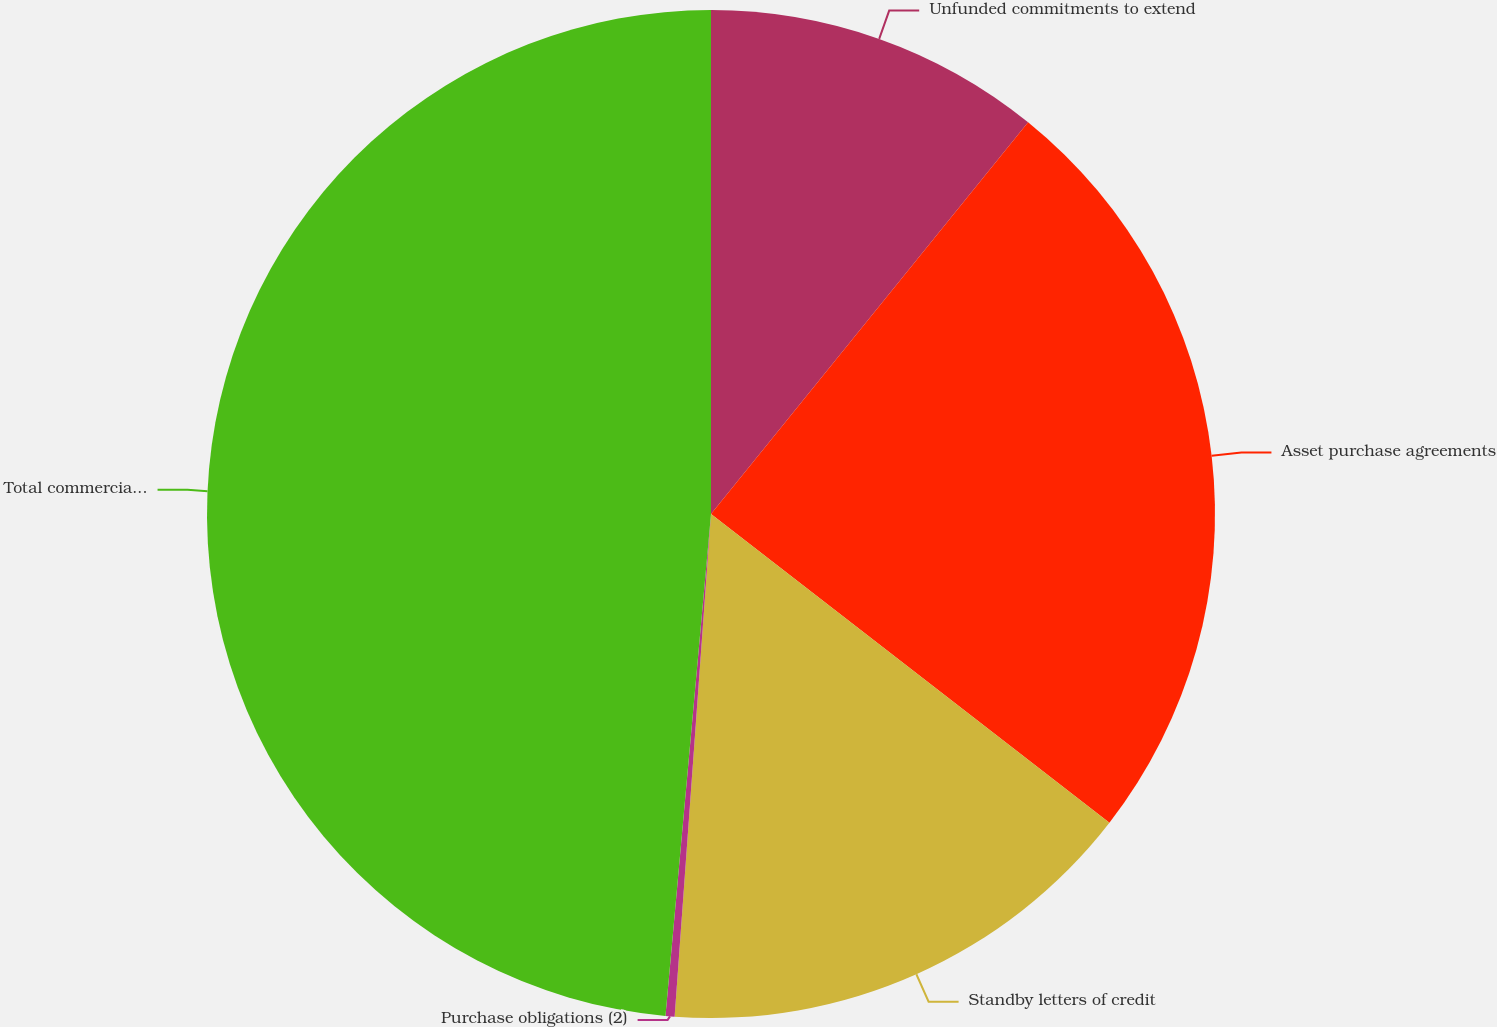Convert chart. <chart><loc_0><loc_0><loc_500><loc_500><pie_chart><fcel>Unfunded commitments to extend<fcel>Asset purchase agreements<fcel>Standby letters of credit<fcel>Purchase obligations (2)<fcel>Total commercial commitments<nl><fcel>10.83%<fcel>24.66%<fcel>15.66%<fcel>0.29%<fcel>48.56%<nl></chart> 